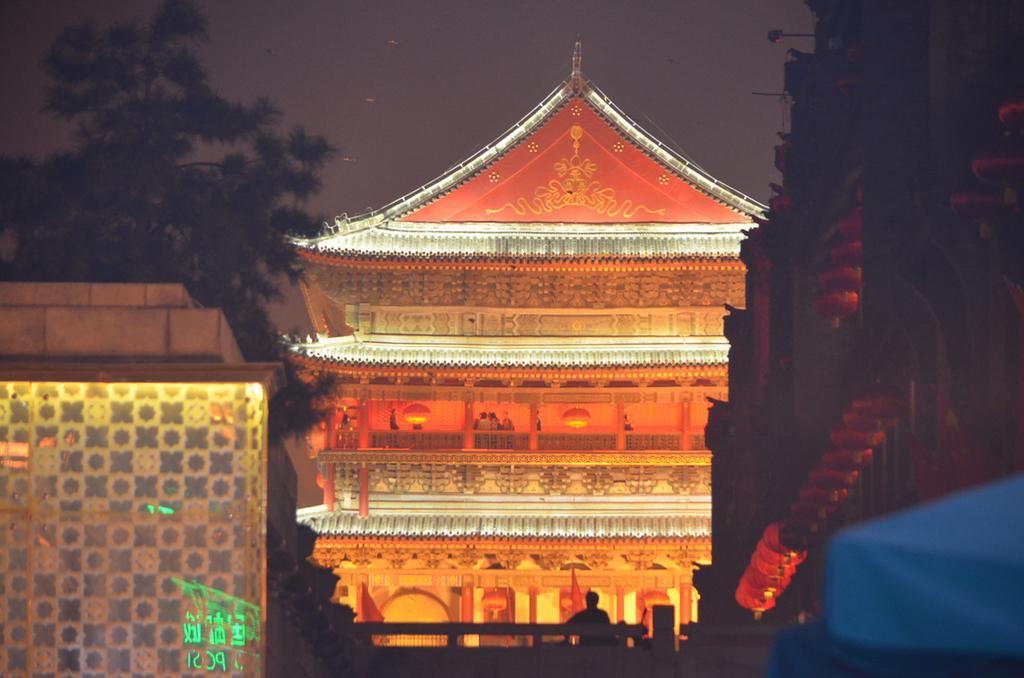In one or two sentences, can you explain what this image depicts? In this picture I can see there are three buildings and in the backdrop I can see there is a building arranged with lights. There is a tree onto left side and the sky is clear. 